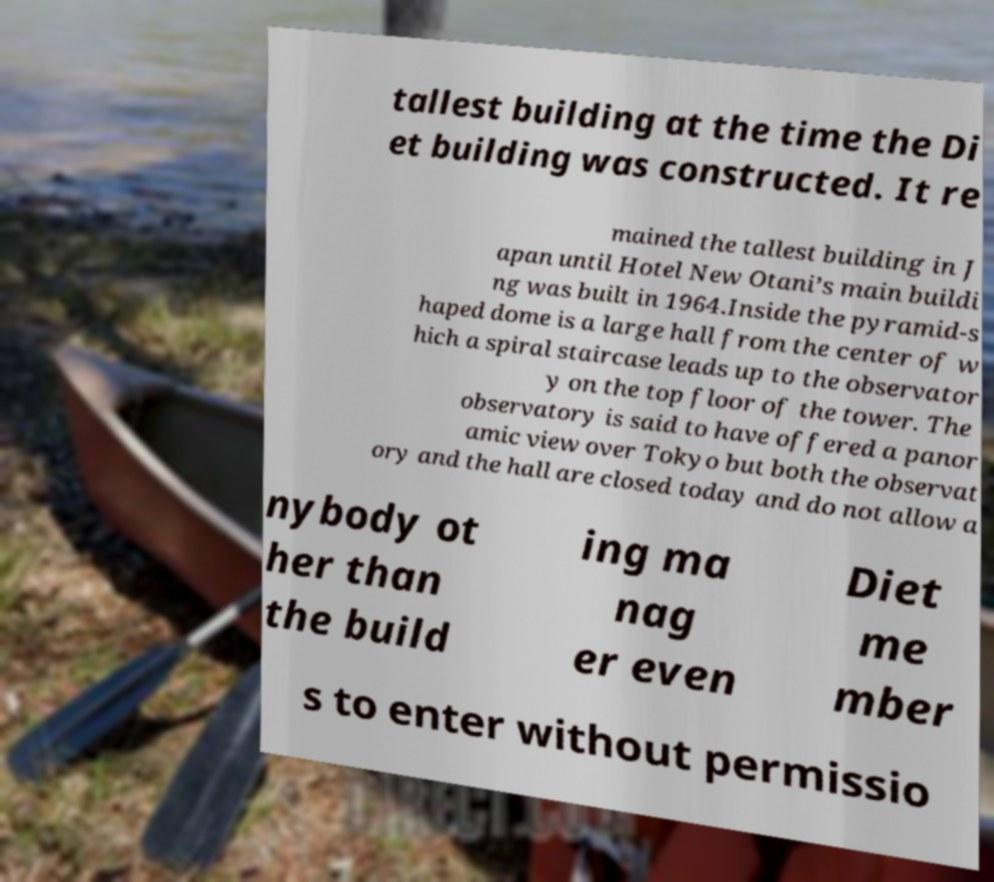Can you read and provide the text displayed in the image?This photo seems to have some interesting text. Can you extract and type it out for me? tallest building at the time the Di et building was constructed. It re mained the tallest building in J apan until Hotel New Otani’s main buildi ng was built in 1964.Inside the pyramid-s haped dome is a large hall from the center of w hich a spiral staircase leads up to the observator y on the top floor of the tower. The observatory is said to have offered a panor amic view over Tokyo but both the observat ory and the hall are closed today and do not allow a nybody ot her than the build ing ma nag er even Diet me mber s to enter without permissio 